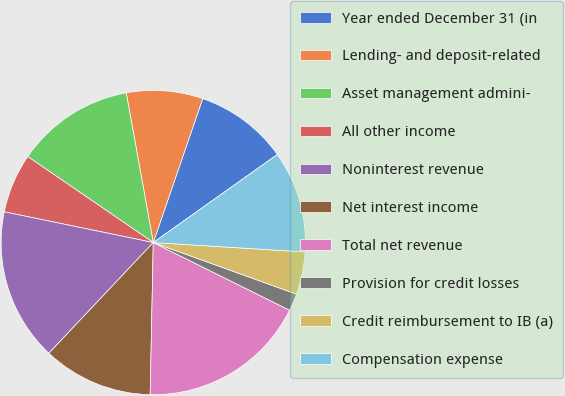Convert chart. <chart><loc_0><loc_0><loc_500><loc_500><pie_chart><fcel>Year ended December 31 (in<fcel>Lending- and deposit-related<fcel>Asset management admini-<fcel>All other income<fcel>Noninterest revenue<fcel>Net interest income<fcel>Total net revenue<fcel>Provision for credit losses<fcel>Credit reimbursement to IB (a)<fcel>Compensation expense<nl><fcel>9.91%<fcel>8.11%<fcel>12.6%<fcel>6.32%<fcel>16.2%<fcel>11.71%<fcel>17.99%<fcel>1.83%<fcel>4.52%<fcel>10.81%<nl></chart> 